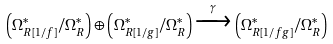<formula> <loc_0><loc_0><loc_500><loc_500>\left ( \Omega ^ { * } _ { R [ 1 / f ] } / \Omega ^ { * } _ { R } \right ) \oplus \left ( \Omega ^ { * } _ { R [ 1 / g ] } / \Omega ^ { * } _ { R } \right ) \xrightarrow { \, \gamma \, } \left ( \Omega ^ { * } _ { R [ 1 / f g ] } / \Omega ^ { * } _ { R } \right )</formula> 